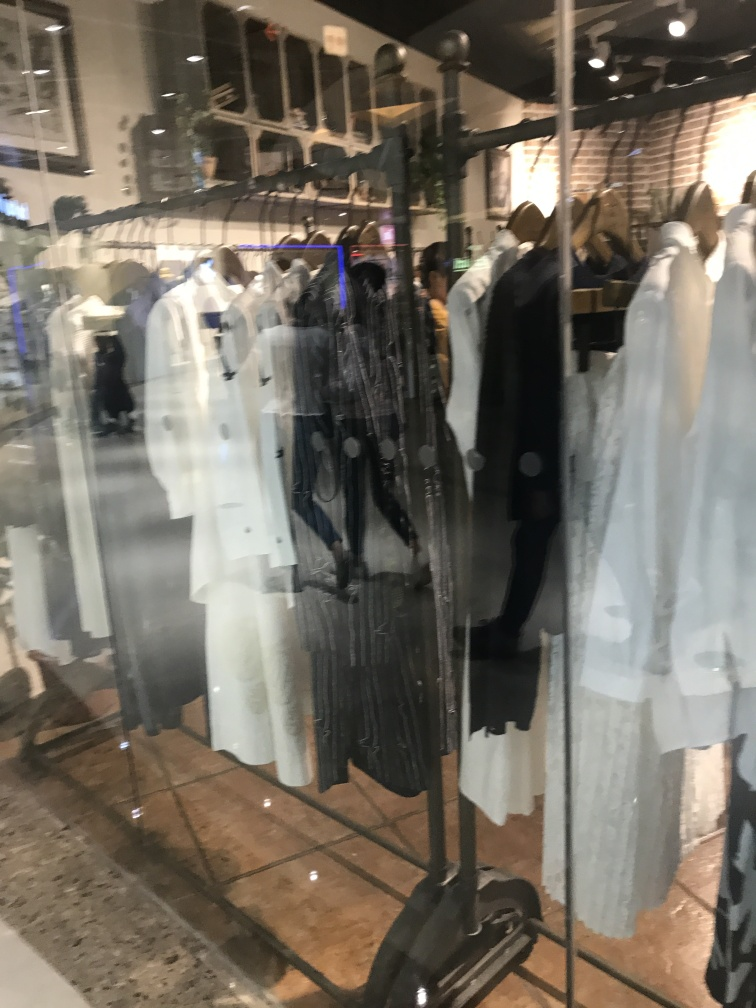Is the composition inclined? From observing the image, it appears that the given composition is somewhat inclined. However, the inclination seems to be a result of the camera angle rather than the actual arrangement of objects in the scene, which suggests that the composition itself, if viewed directly, would likely be aligned. 